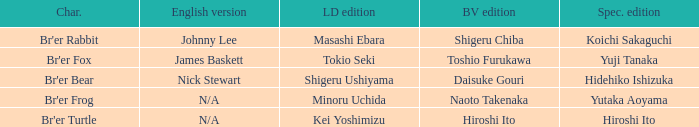Who is the buena vista edidtion where special edition is koichi sakaguchi? Shigeru Chiba. 